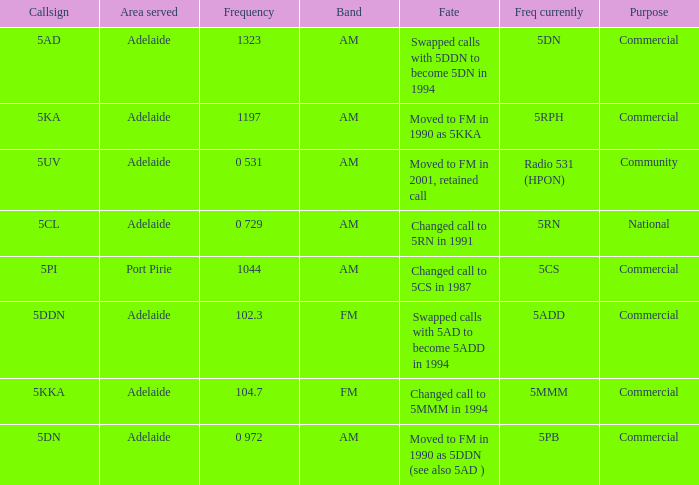What is the current freq for Frequency of 104.7? 5MMM. 